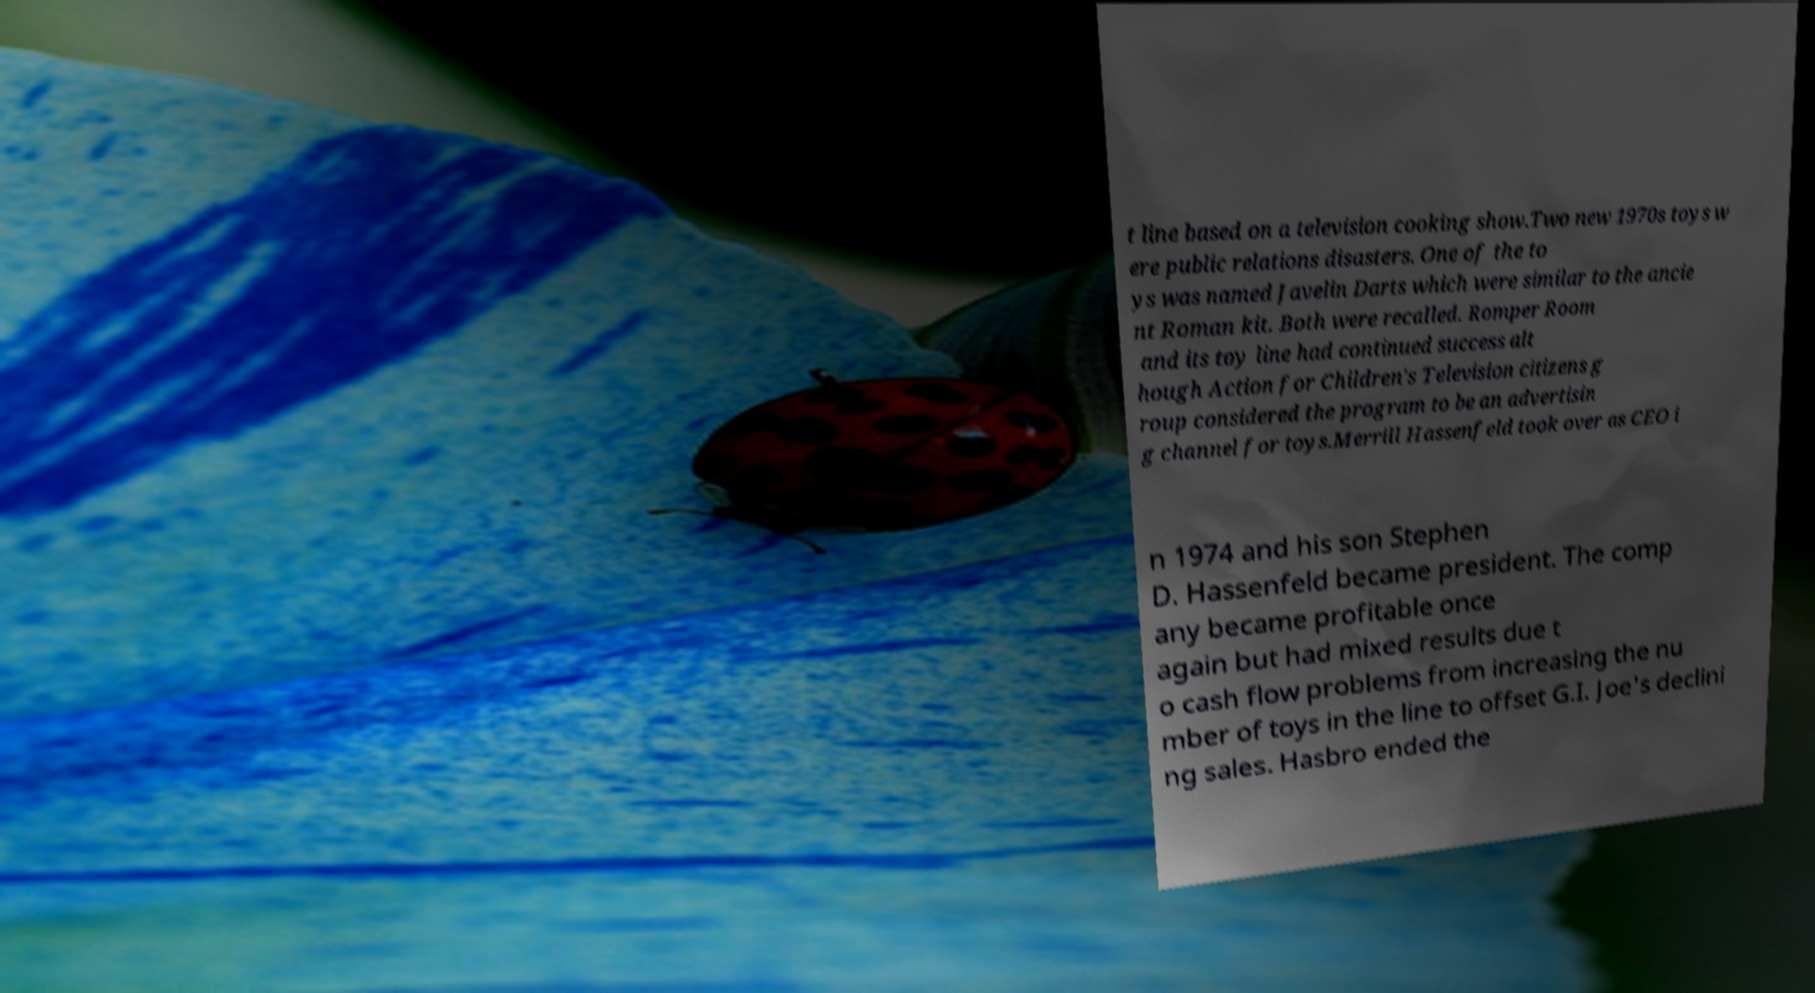There's text embedded in this image that I need extracted. Can you transcribe it verbatim? t line based on a television cooking show.Two new 1970s toys w ere public relations disasters. One of the to ys was named Javelin Darts which were similar to the ancie nt Roman kit. Both were recalled. Romper Room and its toy line had continued success alt hough Action for Children's Television citizens g roup considered the program to be an advertisin g channel for toys.Merrill Hassenfeld took over as CEO i n 1974 and his son Stephen D. Hassenfeld became president. The comp any became profitable once again but had mixed results due t o cash flow problems from increasing the nu mber of toys in the line to offset G.I. Joe's declini ng sales. Hasbro ended the 